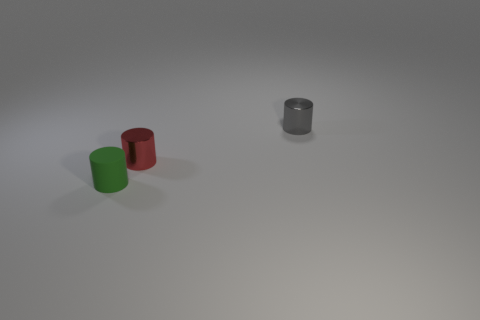Is there anything else that has the same material as the tiny green object?
Give a very brief answer. No. What is the shape of the rubber object that is in front of the tiny metallic thing on the left side of the small metallic object behind the small red metallic object?
Your answer should be compact. Cylinder. How many objects are objects to the right of the small matte cylinder or shiny cylinders that are behind the small red shiny cylinder?
Keep it short and to the point. 2. There is a green cylinder that is in front of the shiny cylinder left of the tiny gray metallic object; what size is it?
Keep it short and to the point. Small. Are there any small gray metallic objects that have the same shape as the tiny rubber thing?
Make the answer very short. Yes. There is a shiny cylinder that is the same size as the red thing; what is its color?
Your answer should be very brief. Gray. There is a small metallic cylinder behind the red cylinder; is there a small rubber cylinder in front of it?
Offer a very short reply. Yes. Is the tiny green object that is in front of the gray cylinder made of the same material as the tiny gray thing?
Make the answer very short. No. What number of small shiny cylinders are both in front of the gray cylinder and behind the red shiny cylinder?
Offer a very short reply. 0. How many small gray things have the same material as the green object?
Provide a succinct answer. 0. 